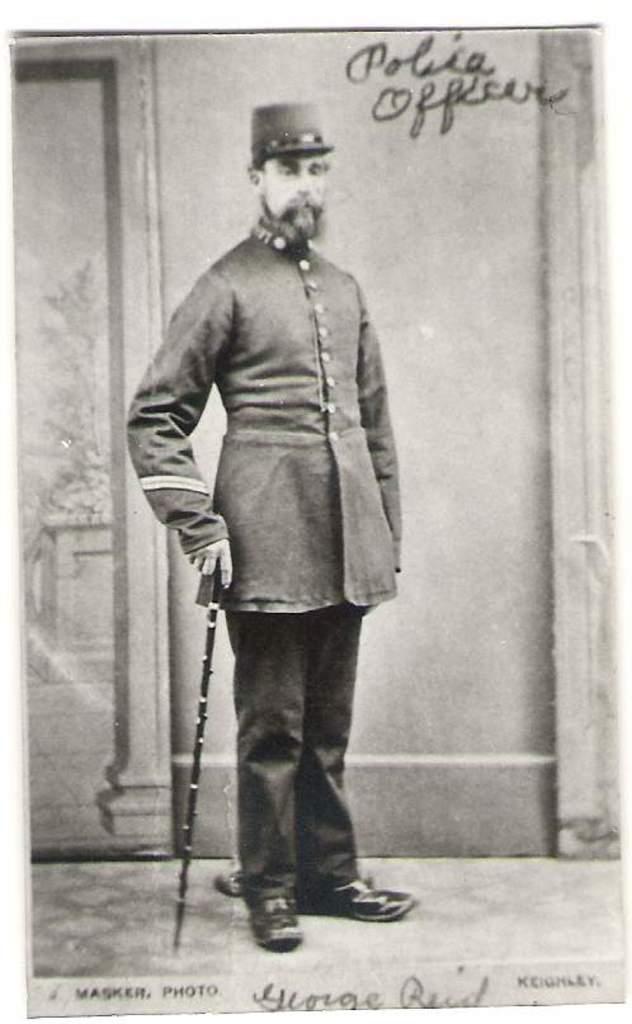What is the name of the public servant worker?
Your answer should be compact. George reid. Who made this photo?
Your response must be concise. George reid. 